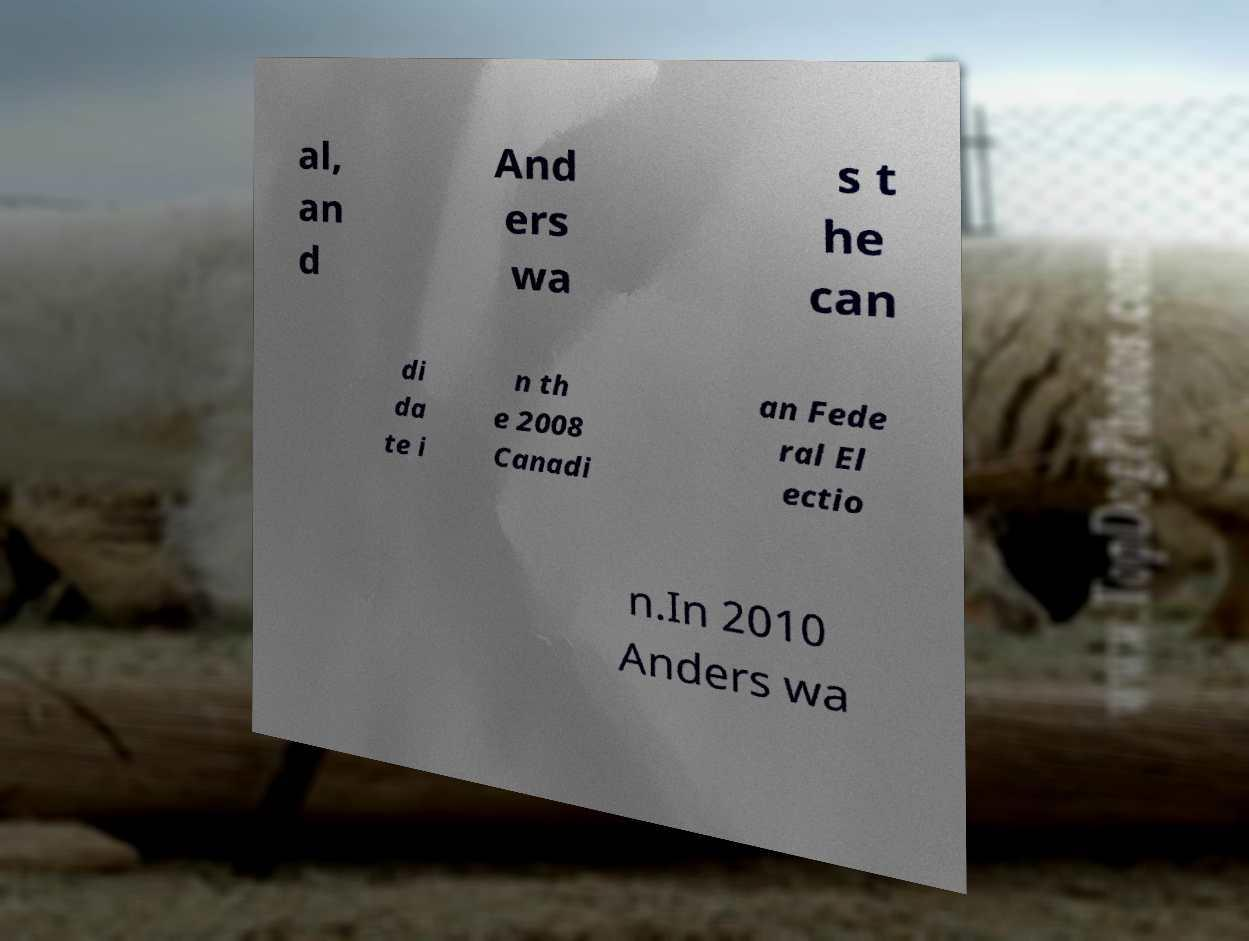What messages or text are displayed in this image? I need them in a readable, typed format. al, an d And ers wa s t he can di da te i n th e 2008 Canadi an Fede ral El ectio n.In 2010 Anders wa 